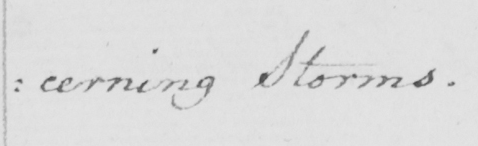Transcribe the text shown in this historical manuscript line. : cerning Storms . 